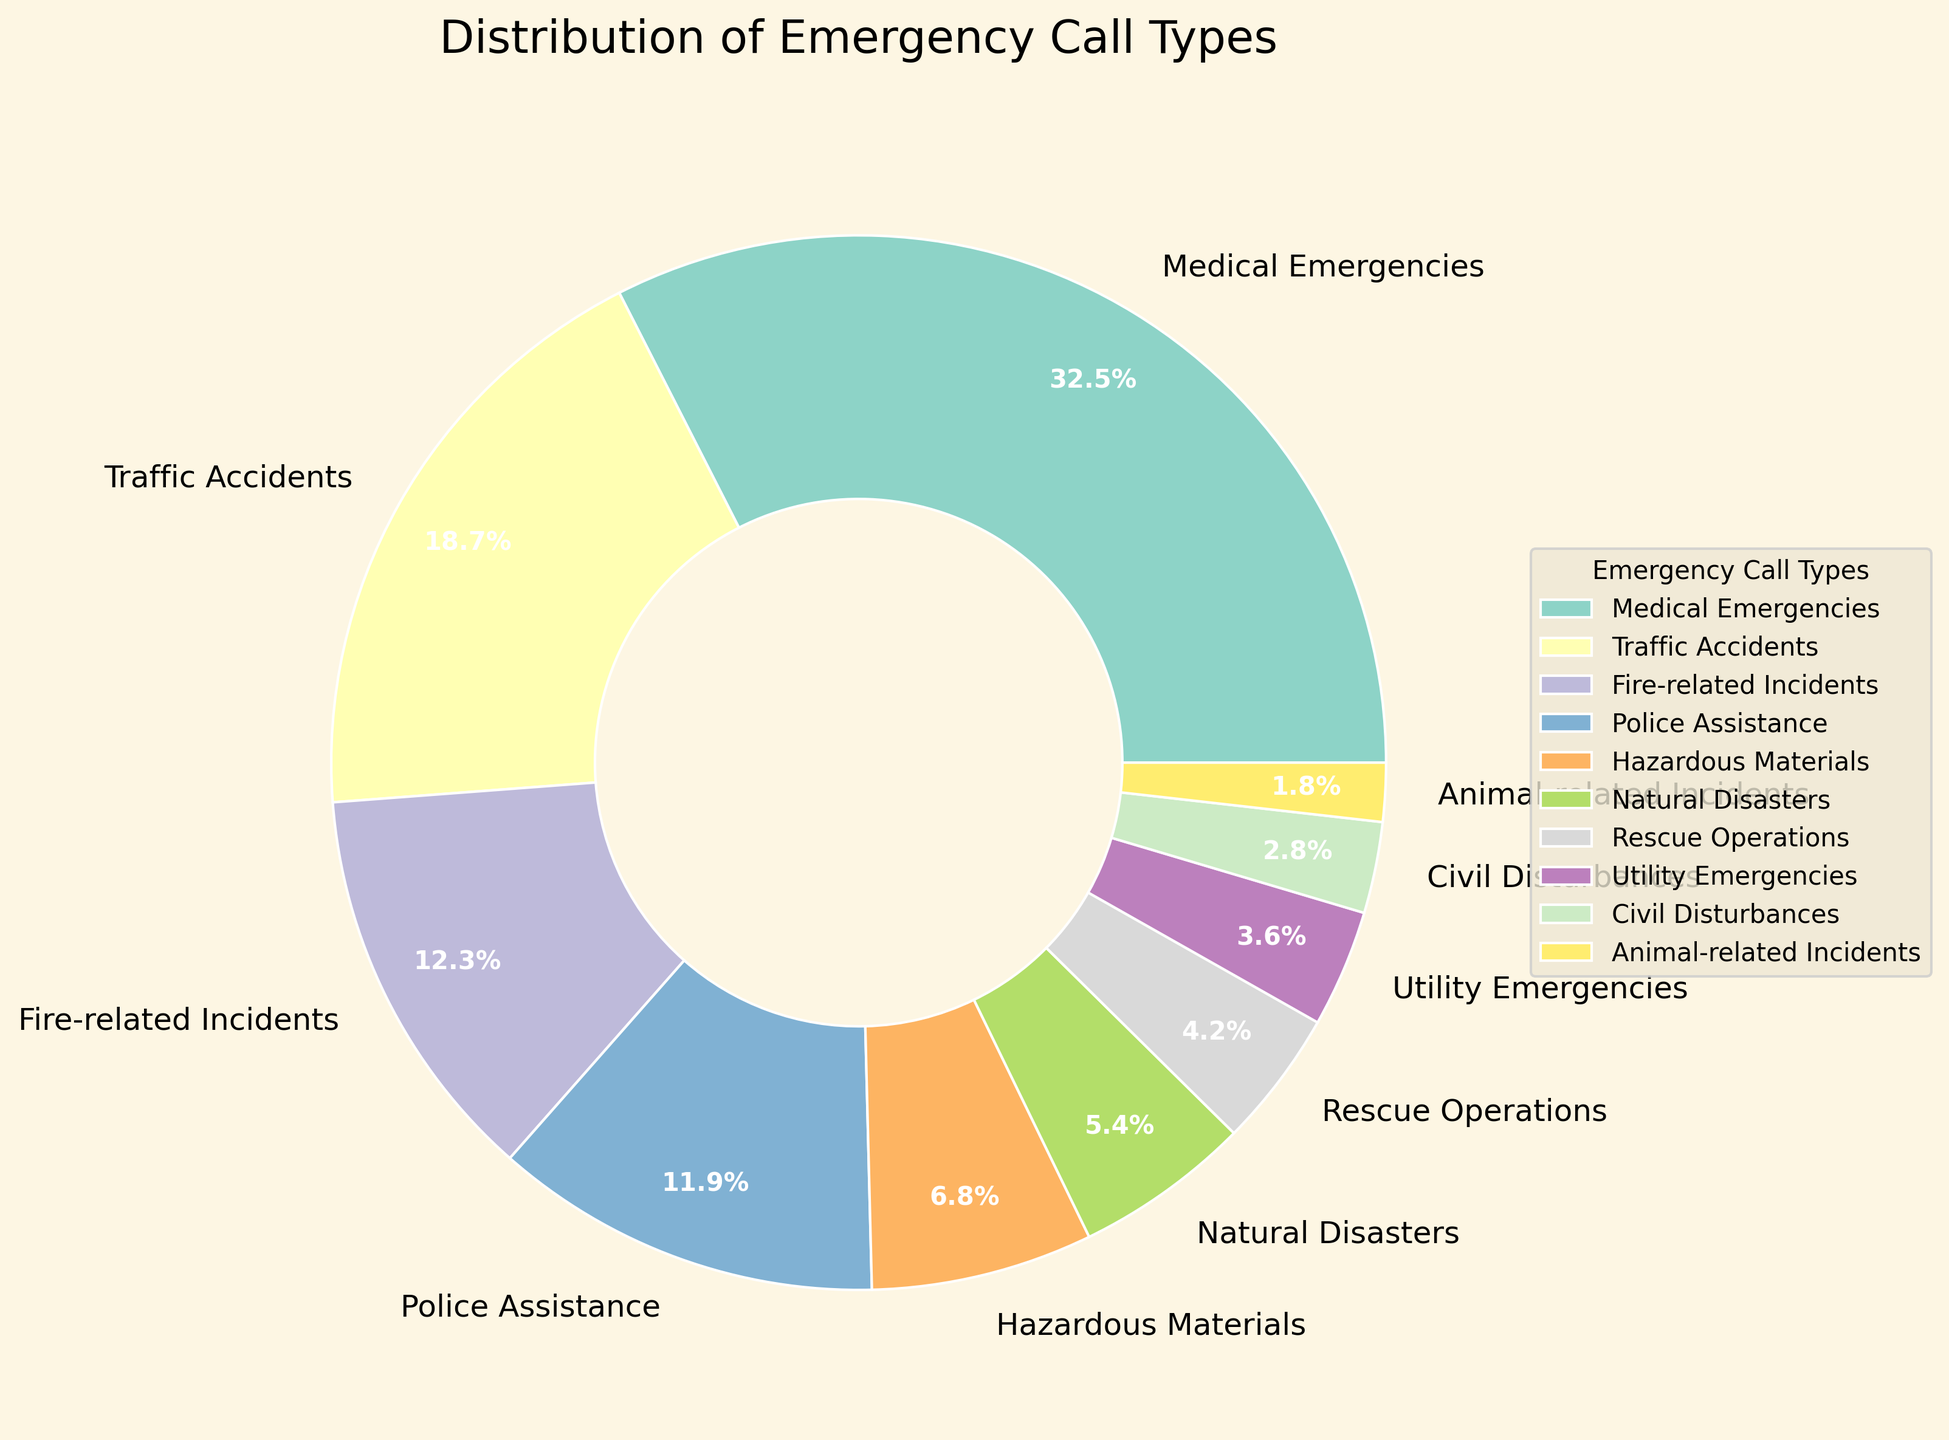What's the most common type of emergency call? The largest wedge of the pie chart represents the most common type of emergency call. By examining the chart, we see that "Medical Emergencies" has the biggest wedge with 32.5%.
Answer: Medical Emergencies Which type of emergency call accounts for the smallest proportion? The smallest wedge in the pie chart represents the least common type of emergency call. By inspecting the chart, "Animal-related Incidents" has the smallest wedge with 1.8%.
Answer: Animal-related Incidents How do traffic accidents compare to natural disasters in terms of percentage? By comparing the wedges for "Traffic Accidents" and "Natural Disasters", we see that "Traffic Accidents" accounts for 18.7%, while "Natural Disasters" accounts for 5.4%. 18.7% is greater than 5.4%.
Answer: Traffic Accidents have a higher percentage What's the combined percentage of fire-related incidents and police assistance calls? To get the combined percentage, we add the percentages of "Fire-related Incidents" (12.3%) and "Police Assistance" (11.9%). 12.3 + 11.9 = 24.2.
Answer: 24.2% Are there more fire-related incidents or utility emergencies? To compare, we look at the percentages. "Fire-related Incidents" account for 12.3%, and "Utility Emergencies" account for 3.6%. 12.3% is greater than 3.6%.
Answer: Fire-related Incidents Which category has the third largest percentage, and what is its value? By looking at the size of the wedges, "Traffic Accidents" is the second largest, and "Fire-related Incidents" is the third largest with a percentage of 12.3%.
Answer: Fire-related Incidents, 12.3% What percentage difference is there between Medical Emergencies and Police Assistance? We subtract the percentage of "Police Assistance" (11.9%) from that of "Medical Emergencies" (32.5%) to find the difference. 32.5 - 11.9 = 20.6.
Answer: 20.6% Which emergency type closest to 5% makes up the calls, and what is the exact percentage? By examining the chart, "Natural Disasters" have a wedge closest to 5%, with a percentage of 5.4%.
Answer: Natural Disasters, 5.4% What is the combined percentage for categories accounting for less than 5% each? Adding the categories under 5%: "Rescue Operations" (4.2%), "Utility Emergencies" (3.6%), "Civil Disturbances" (2.8%), and "Animal-related Incidents" (1.8%). 4.2 + 3.6 + 2.8 + 1.8 = 12.4%.
Answer: 12.4% 